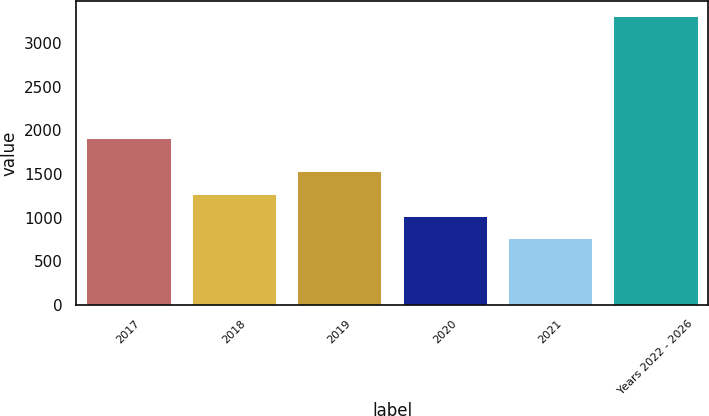Convert chart. <chart><loc_0><loc_0><loc_500><loc_500><bar_chart><fcel>2017<fcel>2018<fcel>2019<fcel>2020<fcel>2021<fcel>Years 2022 - 2026<nl><fcel>1911<fcel>1274.6<fcel>1528.9<fcel>1020.3<fcel>766<fcel>3309<nl></chart> 